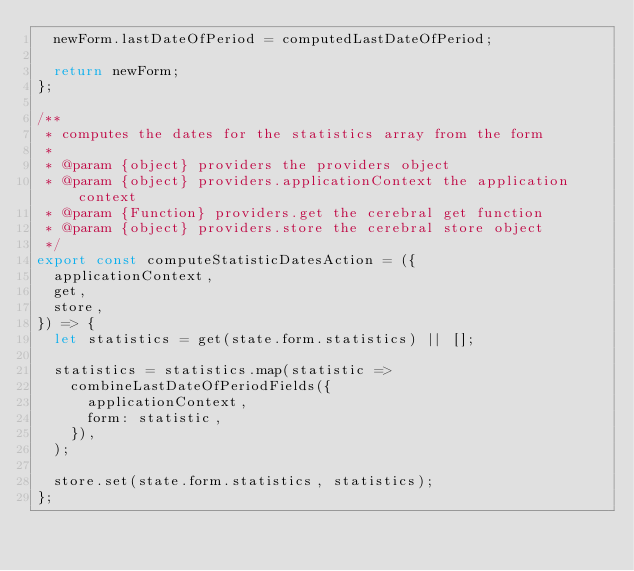Convert code to text. <code><loc_0><loc_0><loc_500><loc_500><_JavaScript_>  newForm.lastDateOfPeriod = computedLastDateOfPeriod;

  return newForm;
};

/**
 * computes the dates for the statistics array from the form
 *
 * @param {object} providers the providers object
 * @param {object} providers.applicationContext the application context
 * @param {Function} providers.get the cerebral get function
 * @param {object} providers.store the cerebral store object
 */
export const computeStatisticDatesAction = ({
  applicationContext,
  get,
  store,
}) => {
  let statistics = get(state.form.statistics) || [];

  statistics = statistics.map(statistic =>
    combineLastDateOfPeriodFields({
      applicationContext,
      form: statistic,
    }),
  );

  store.set(state.form.statistics, statistics);
};
</code> 